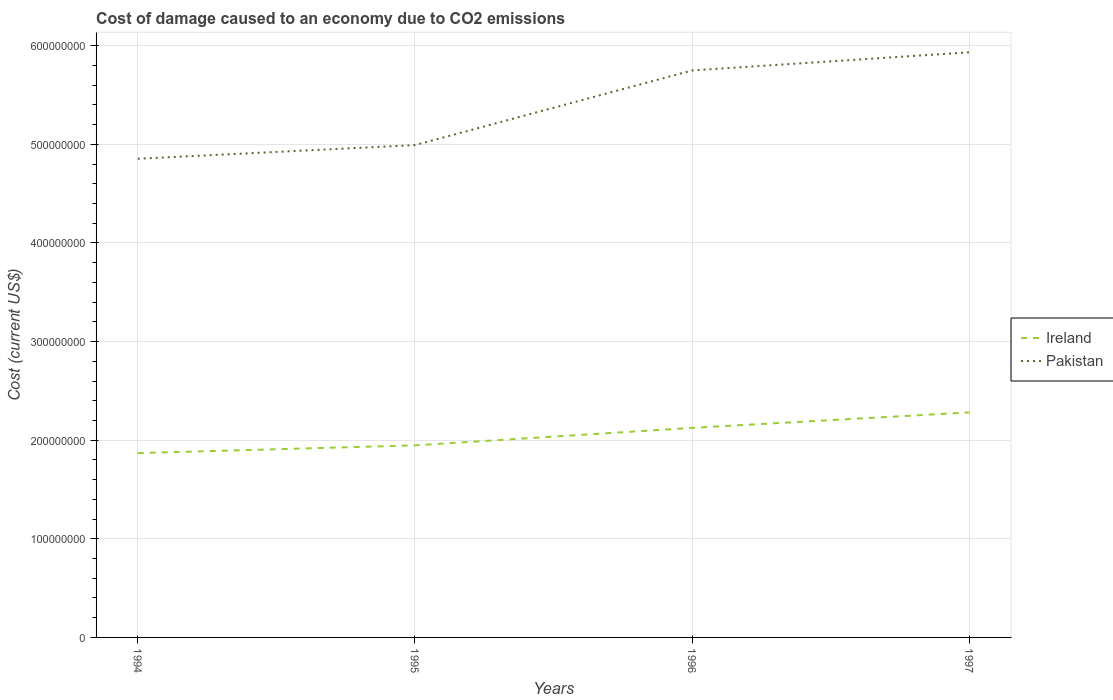Is the number of lines equal to the number of legend labels?
Ensure brevity in your answer.  Yes. Across all years, what is the maximum cost of damage caused due to CO2 emissisons in Ireland?
Provide a succinct answer. 1.87e+08. In which year was the cost of damage caused due to CO2 emissisons in Ireland maximum?
Keep it short and to the point. 1994. What is the total cost of damage caused due to CO2 emissisons in Pakistan in the graph?
Offer a terse response. -9.41e+07. What is the difference between the highest and the second highest cost of damage caused due to CO2 emissisons in Pakistan?
Make the answer very short. 1.08e+08. Is the cost of damage caused due to CO2 emissisons in Ireland strictly greater than the cost of damage caused due to CO2 emissisons in Pakistan over the years?
Make the answer very short. Yes. What is the difference between two consecutive major ticks on the Y-axis?
Provide a succinct answer. 1.00e+08. Where does the legend appear in the graph?
Your answer should be very brief. Center right. How many legend labels are there?
Your answer should be compact. 2. How are the legend labels stacked?
Your answer should be compact. Vertical. What is the title of the graph?
Keep it short and to the point. Cost of damage caused to an economy due to CO2 emissions. Does "Afghanistan" appear as one of the legend labels in the graph?
Ensure brevity in your answer.  No. What is the label or title of the X-axis?
Ensure brevity in your answer.  Years. What is the label or title of the Y-axis?
Ensure brevity in your answer.  Cost (current US$). What is the Cost (current US$) of Ireland in 1994?
Give a very brief answer. 1.87e+08. What is the Cost (current US$) in Pakistan in 1994?
Offer a very short reply. 4.85e+08. What is the Cost (current US$) of Ireland in 1995?
Offer a very short reply. 1.95e+08. What is the Cost (current US$) of Pakistan in 1995?
Make the answer very short. 4.99e+08. What is the Cost (current US$) of Ireland in 1996?
Offer a terse response. 2.13e+08. What is the Cost (current US$) of Pakistan in 1996?
Keep it short and to the point. 5.75e+08. What is the Cost (current US$) in Ireland in 1997?
Keep it short and to the point. 2.28e+08. What is the Cost (current US$) of Pakistan in 1997?
Offer a terse response. 5.93e+08. Across all years, what is the maximum Cost (current US$) of Ireland?
Make the answer very short. 2.28e+08. Across all years, what is the maximum Cost (current US$) of Pakistan?
Your answer should be compact. 5.93e+08. Across all years, what is the minimum Cost (current US$) of Ireland?
Provide a short and direct response. 1.87e+08. Across all years, what is the minimum Cost (current US$) of Pakistan?
Keep it short and to the point. 4.85e+08. What is the total Cost (current US$) in Ireland in the graph?
Your answer should be very brief. 8.22e+08. What is the total Cost (current US$) of Pakistan in the graph?
Make the answer very short. 2.15e+09. What is the difference between the Cost (current US$) of Ireland in 1994 and that in 1995?
Provide a succinct answer. -7.85e+06. What is the difference between the Cost (current US$) in Pakistan in 1994 and that in 1995?
Your answer should be compact. -1.38e+07. What is the difference between the Cost (current US$) of Ireland in 1994 and that in 1996?
Offer a very short reply. -2.56e+07. What is the difference between the Cost (current US$) of Pakistan in 1994 and that in 1996?
Keep it short and to the point. -8.96e+07. What is the difference between the Cost (current US$) in Ireland in 1994 and that in 1997?
Offer a very short reply. -4.13e+07. What is the difference between the Cost (current US$) of Pakistan in 1994 and that in 1997?
Provide a short and direct response. -1.08e+08. What is the difference between the Cost (current US$) of Ireland in 1995 and that in 1996?
Provide a succinct answer. -1.78e+07. What is the difference between the Cost (current US$) of Pakistan in 1995 and that in 1996?
Provide a succinct answer. -7.57e+07. What is the difference between the Cost (current US$) in Ireland in 1995 and that in 1997?
Provide a short and direct response. -3.34e+07. What is the difference between the Cost (current US$) of Pakistan in 1995 and that in 1997?
Your answer should be compact. -9.41e+07. What is the difference between the Cost (current US$) of Ireland in 1996 and that in 1997?
Your response must be concise. -1.57e+07. What is the difference between the Cost (current US$) of Pakistan in 1996 and that in 1997?
Ensure brevity in your answer.  -1.84e+07. What is the difference between the Cost (current US$) of Ireland in 1994 and the Cost (current US$) of Pakistan in 1995?
Provide a succinct answer. -3.12e+08. What is the difference between the Cost (current US$) of Ireland in 1994 and the Cost (current US$) of Pakistan in 1996?
Your response must be concise. -3.88e+08. What is the difference between the Cost (current US$) of Ireland in 1994 and the Cost (current US$) of Pakistan in 1997?
Offer a terse response. -4.06e+08. What is the difference between the Cost (current US$) in Ireland in 1995 and the Cost (current US$) in Pakistan in 1996?
Give a very brief answer. -3.80e+08. What is the difference between the Cost (current US$) of Ireland in 1995 and the Cost (current US$) of Pakistan in 1997?
Make the answer very short. -3.99e+08. What is the difference between the Cost (current US$) of Ireland in 1996 and the Cost (current US$) of Pakistan in 1997?
Offer a terse response. -3.81e+08. What is the average Cost (current US$) of Ireland per year?
Give a very brief answer. 2.06e+08. What is the average Cost (current US$) of Pakistan per year?
Offer a very short reply. 5.38e+08. In the year 1994, what is the difference between the Cost (current US$) in Ireland and Cost (current US$) in Pakistan?
Give a very brief answer. -2.98e+08. In the year 1995, what is the difference between the Cost (current US$) of Ireland and Cost (current US$) of Pakistan?
Keep it short and to the point. -3.04e+08. In the year 1996, what is the difference between the Cost (current US$) in Ireland and Cost (current US$) in Pakistan?
Provide a short and direct response. -3.62e+08. In the year 1997, what is the difference between the Cost (current US$) in Ireland and Cost (current US$) in Pakistan?
Your answer should be very brief. -3.65e+08. What is the ratio of the Cost (current US$) of Ireland in 1994 to that in 1995?
Your answer should be very brief. 0.96. What is the ratio of the Cost (current US$) of Pakistan in 1994 to that in 1995?
Your answer should be very brief. 0.97. What is the ratio of the Cost (current US$) of Ireland in 1994 to that in 1996?
Provide a succinct answer. 0.88. What is the ratio of the Cost (current US$) of Pakistan in 1994 to that in 1996?
Provide a short and direct response. 0.84. What is the ratio of the Cost (current US$) of Ireland in 1994 to that in 1997?
Make the answer very short. 0.82. What is the ratio of the Cost (current US$) in Pakistan in 1994 to that in 1997?
Make the answer very short. 0.82. What is the ratio of the Cost (current US$) in Ireland in 1995 to that in 1996?
Offer a terse response. 0.92. What is the ratio of the Cost (current US$) of Pakistan in 1995 to that in 1996?
Make the answer very short. 0.87. What is the ratio of the Cost (current US$) in Ireland in 1995 to that in 1997?
Offer a very short reply. 0.85. What is the ratio of the Cost (current US$) in Pakistan in 1995 to that in 1997?
Your response must be concise. 0.84. What is the ratio of the Cost (current US$) in Ireland in 1996 to that in 1997?
Your response must be concise. 0.93. What is the difference between the highest and the second highest Cost (current US$) of Ireland?
Make the answer very short. 1.57e+07. What is the difference between the highest and the second highest Cost (current US$) in Pakistan?
Offer a terse response. 1.84e+07. What is the difference between the highest and the lowest Cost (current US$) in Ireland?
Offer a terse response. 4.13e+07. What is the difference between the highest and the lowest Cost (current US$) of Pakistan?
Offer a terse response. 1.08e+08. 